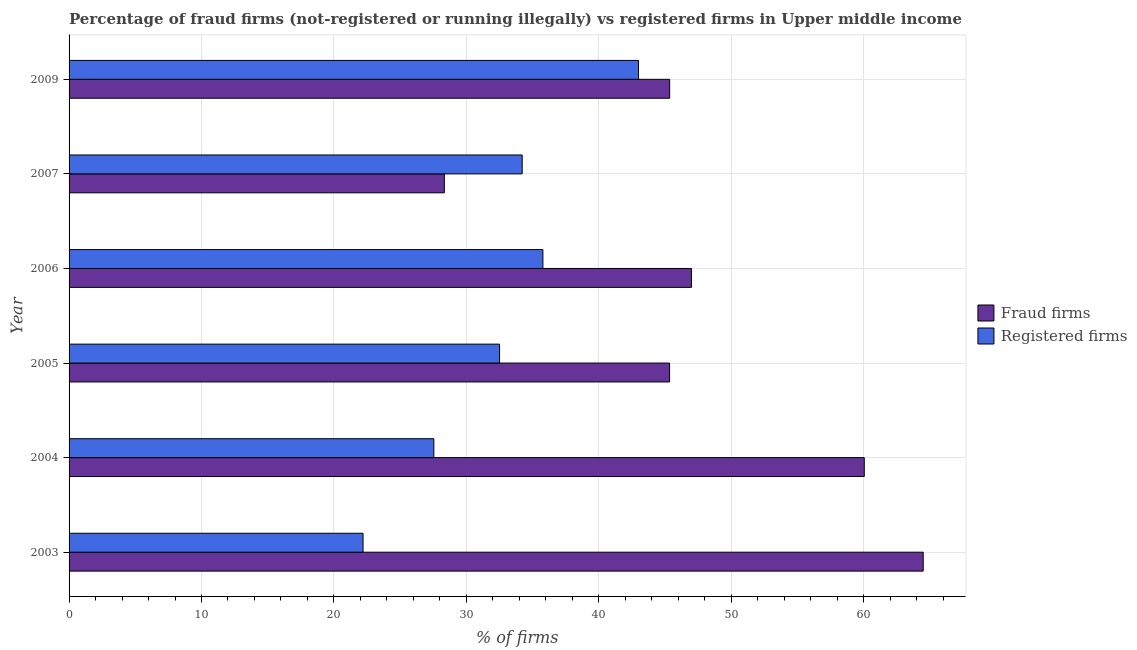How many groups of bars are there?
Make the answer very short. 6. Are the number of bars per tick equal to the number of legend labels?
Your answer should be very brief. Yes. How many bars are there on the 6th tick from the top?
Offer a terse response. 2. What is the percentage of fraud firms in 2005?
Your response must be concise. 45.35. Across all years, what is the minimum percentage of registered firms?
Offer a terse response. 22.2. What is the total percentage of fraud firms in the graph?
Give a very brief answer. 290.59. What is the difference between the percentage of registered firms in 2003 and that in 2006?
Offer a terse response. -13.58. What is the difference between the percentage of registered firms in 2003 and the percentage of fraud firms in 2004?
Your response must be concise. -37.85. What is the average percentage of fraud firms per year?
Give a very brief answer. 48.43. In the year 2006, what is the difference between the percentage of registered firms and percentage of fraud firms?
Offer a very short reply. -11.22. Is the percentage of fraud firms in 2004 less than that in 2006?
Keep it short and to the point. No. What is the difference between the highest and the second highest percentage of fraud firms?
Ensure brevity in your answer.  4.45. What is the difference between the highest and the lowest percentage of registered firms?
Keep it short and to the point. 20.8. What does the 1st bar from the top in 2009 represents?
Make the answer very short. Registered firms. What does the 2nd bar from the bottom in 2003 represents?
Your response must be concise. Registered firms. How many bars are there?
Give a very brief answer. 12. What is the difference between two consecutive major ticks on the X-axis?
Provide a succinct answer. 10. Does the graph contain any zero values?
Your answer should be compact. No. Does the graph contain grids?
Your answer should be very brief. Yes. How many legend labels are there?
Offer a terse response. 2. What is the title of the graph?
Your answer should be very brief. Percentage of fraud firms (not-registered or running illegally) vs registered firms in Upper middle income. Does "Chemicals" appear as one of the legend labels in the graph?
Offer a very short reply. No. What is the label or title of the X-axis?
Keep it short and to the point. % of firms. What is the % of firms of Fraud firms in 2003?
Your answer should be compact. 64.5. What is the % of firms of Fraud firms in 2004?
Offer a terse response. 60.05. What is the % of firms in Registered firms in 2004?
Ensure brevity in your answer.  27.55. What is the % of firms of Fraud firms in 2005?
Provide a short and direct response. 45.35. What is the % of firms in Registered firms in 2005?
Your response must be concise. 32.51. What is the % of firms in Fraud firms in 2006?
Give a very brief answer. 47. What is the % of firms in Registered firms in 2006?
Keep it short and to the point. 35.78. What is the % of firms of Fraud firms in 2007?
Give a very brief answer. 28.34. What is the % of firms in Registered firms in 2007?
Keep it short and to the point. 34.22. What is the % of firms of Fraud firms in 2009?
Provide a short and direct response. 45.35. Across all years, what is the maximum % of firms in Fraud firms?
Offer a terse response. 64.5. Across all years, what is the maximum % of firms in Registered firms?
Make the answer very short. 43. Across all years, what is the minimum % of firms in Fraud firms?
Provide a succinct answer. 28.34. Across all years, what is the minimum % of firms of Registered firms?
Offer a very short reply. 22.2. What is the total % of firms in Fraud firms in the graph?
Ensure brevity in your answer.  290.59. What is the total % of firms in Registered firms in the graph?
Offer a very short reply. 195.25. What is the difference between the % of firms of Fraud firms in 2003 and that in 2004?
Your response must be concise. 4.45. What is the difference between the % of firms in Registered firms in 2003 and that in 2004?
Your answer should be compact. -5.35. What is the difference between the % of firms in Fraud firms in 2003 and that in 2005?
Give a very brief answer. 19.15. What is the difference between the % of firms in Registered firms in 2003 and that in 2005?
Offer a very short reply. -10.31. What is the difference between the % of firms of Fraud firms in 2003 and that in 2006?
Your response must be concise. 17.5. What is the difference between the % of firms in Registered firms in 2003 and that in 2006?
Give a very brief answer. -13.58. What is the difference between the % of firms of Fraud firms in 2003 and that in 2007?
Give a very brief answer. 36.16. What is the difference between the % of firms in Registered firms in 2003 and that in 2007?
Make the answer very short. -12.02. What is the difference between the % of firms of Fraud firms in 2003 and that in 2009?
Make the answer very short. 19.15. What is the difference between the % of firms in Registered firms in 2003 and that in 2009?
Make the answer very short. -20.8. What is the difference between the % of firms of Fraud firms in 2004 and that in 2005?
Give a very brief answer. 14.7. What is the difference between the % of firms of Registered firms in 2004 and that in 2005?
Offer a terse response. -4.96. What is the difference between the % of firms of Fraud firms in 2004 and that in 2006?
Your response must be concise. 13.05. What is the difference between the % of firms in Registered firms in 2004 and that in 2006?
Provide a succinct answer. -8.23. What is the difference between the % of firms of Fraud firms in 2004 and that in 2007?
Your response must be concise. 31.71. What is the difference between the % of firms of Registered firms in 2004 and that in 2007?
Make the answer very short. -6.67. What is the difference between the % of firms in Fraud firms in 2004 and that in 2009?
Make the answer very short. 14.7. What is the difference between the % of firms in Registered firms in 2004 and that in 2009?
Offer a very short reply. -15.45. What is the difference between the % of firms of Fraud firms in 2005 and that in 2006?
Your answer should be very brief. -1.65. What is the difference between the % of firms of Registered firms in 2005 and that in 2006?
Offer a terse response. -3.27. What is the difference between the % of firms in Fraud firms in 2005 and that in 2007?
Offer a very short reply. 17.01. What is the difference between the % of firms of Registered firms in 2005 and that in 2007?
Give a very brief answer. -1.71. What is the difference between the % of firms of Fraud firms in 2005 and that in 2009?
Your answer should be compact. -0.01. What is the difference between the % of firms in Registered firms in 2005 and that in 2009?
Your answer should be compact. -10.49. What is the difference between the % of firms in Fraud firms in 2006 and that in 2007?
Make the answer very short. 18.66. What is the difference between the % of firms in Registered firms in 2006 and that in 2007?
Provide a succinct answer. 1.56. What is the difference between the % of firms of Fraud firms in 2006 and that in 2009?
Offer a terse response. 1.64. What is the difference between the % of firms in Registered firms in 2006 and that in 2009?
Keep it short and to the point. -7.22. What is the difference between the % of firms of Fraud firms in 2007 and that in 2009?
Make the answer very short. -17.01. What is the difference between the % of firms in Registered firms in 2007 and that in 2009?
Keep it short and to the point. -8.78. What is the difference between the % of firms of Fraud firms in 2003 and the % of firms of Registered firms in 2004?
Make the answer very short. 36.95. What is the difference between the % of firms of Fraud firms in 2003 and the % of firms of Registered firms in 2005?
Offer a very short reply. 31.99. What is the difference between the % of firms of Fraud firms in 2003 and the % of firms of Registered firms in 2006?
Provide a succinct answer. 28.72. What is the difference between the % of firms of Fraud firms in 2003 and the % of firms of Registered firms in 2007?
Provide a succinct answer. 30.28. What is the difference between the % of firms of Fraud firms in 2004 and the % of firms of Registered firms in 2005?
Provide a short and direct response. 27.54. What is the difference between the % of firms of Fraud firms in 2004 and the % of firms of Registered firms in 2006?
Give a very brief answer. 24.27. What is the difference between the % of firms in Fraud firms in 2004 and the % of firms in Registered firms in 2007?
Give a very brief answer. 25.83. What is the difference between the % of firms of Fraud firms in 2004 and the % of firms of Registered firms in 2009?
Your answer should be compact. 17.05. What is the difference between the % of firms of Fraud firms in 2005 and the % of firms of Registered firms in 2006?
Provide a succinct answer. 9.57. What is the difference between the % of firms of Fraud firms in 2005 and the % of firms of Registered firms in 2007?
Keep it short and to the point. 11.13. What is the difference between the % of firms of Fraud firms in 2005 and the % of firms of Registered firms in 2009?
Make the answer very short. 2.35. What is the difference between the % of firms in Fraud firms in 2006 and the % of firms in Registered firms in 2007?
Your answer should be very brief. 12.78. What is the difference between the % of firms of Fraud firms in 2006 and the % of firms of Registered firms in 2009?
Give a very brief answer. 4. What is the difference between the % of firms of Fraud firms in 2007 and the % of firms of Registered firms in 2009?
Ensure brevity in your answer.  -14.66. What is the average % of firms in Fraud firms per year?
Keep it short and to the point. 48.43. What is the average % of firms in Registered firms per year?
Provide a short and direct response. 32.54. In the year 2003, what is the difference between the % of firms of Fraud firms and % of firms of Registered firms?
Your answer should be very brief. 42.3. In the year 2004, what is the difference between the % of firms in Fraud firms and % of firms in Registered firms?
Provide a short and direct response. 32.5. In the year 2005, what is the difference between the % of firms in Fraud firms and % of firms in Registered firms?
Keep it short and to the point. 12.84. In the year 2006, what is the difference between the % of firms in Fraud firms and % of firms in Registered firms?
Offer a terse response. 11.22. In the year 2007, what is the difference between the % of firms of Fraud firms and % of firms of Registered firms?
Offer a very short reply. -5.88. In the year 2009, what is the difference between the % of firms of Fraud firms and % of firms of Registered firms?
Keep it short and to the point. 2.35. What is the ratio of the % of firms of Fraud firms in 2003 to that in 2004?
Your response must be concise. 1.07. What is the ratio of the % of firms in Registered firms in 2003 to that in 2004?
Offer a very short reply. 0.81. What is the ratio of the % of firms of Fraud firms in 2003 to that in 2005?
Offer a terse response. 1.42. What is the ratio of the % of firms of Registered firms in 2003 to that in 2005?
Provide a short and direct response. 0.68. What is the ratio of the % of firms in Fraud firms in 2003 to that in 2006?
Provide a short and direct response. 1.37. What is the ratio of the % of firms of Registered firms in 2003 to that in 2006?
Ensure brevity in your answer.  0.62. What is the ratio of the % of firms of Fraud firms in 2003 to that in 2007?
Offer a terse response. 2.28. What is the ratio of the % of firms in Registered firms in 2003 to that in 2007?
Ensure brevity in your answer.  0.65. What is the ratio of the % of firms of Fraud firms in 2003 to that in 2009?
Your answer should be compact. 1.42. What is the ratio of the % of firms of Registered firms in 2003 to that in 2009?
Keep it short and to the point. 0.52. What is the ratio of the % of firms of Fraud firms in 2004 to that in 2005?
Ensure brevity in your answer.  1.32. What is the ratio of the % of firms in Registered firms in 2004 to that in 2005?
Make the answer very short. 0.85. What is the ratio of the % of firms of Fraud firms in 2004 to that in 2006?
Offer a very short reply. 1.28. What is the ratio of the % of firms in Registered firms in 2004 to that in 2006?
Your response must be concise. 0.77. What is the ratio of the % of firms of Fraud firms in 2004 to that in 2007?
Offer a very short reply. 2.12. What is the ratio of the % of firms in Registered firms in 2004 to that in 2007?
Offer a very short reply. 0.81. What is the ratio of the % of firms of Fraud firms in 2004 to that in 2009?
Provide a short and direct response. 1.32. What is the ratio of the % of firms of Registered firms in 2004 to that in 2009?
Provide a short and direct response. 0.64. What is the ratio of the % of firms in Fraud firms in 2005 to that in 2006?
Your answer should be very brief. 0.96. What is the ratio of the % of firms of Registered firms in 2005 to that in 2006?
Offer a terse response. 0.91. What is the ratio of the % of firms of Fraud firms in 2005 to that in 2007?
Provide a short and direct response. 1.6. What is the ratio of the % of firms in Registered firms in 2005 to that in 2007?
Keep it short and to the point. 0.95. What is the ratio of the % of firms in Registered firms in 2005 to that in 2009?
Your answer should be very brief. 0.76. What is the ratio of the % of firms in Fraud firms in 2006 to that in 2007?
Make the answer very short. 1.66. What is the ratio of the % of firms in Registered firms in 2006 to that in 2007?
Offer a terse response. 1.05. What is the ratio of the % of firms in Fraud firms in 2006 to that in 2009?
Your answer should be very brief. 1.04. What is the ratio of the % of firms in Registered firms in 2006 to that in 2009?
Provide a succinct answer. 0.83. What is the ratio of the % of firms in Fraud firms in 2007 to that in 2009?
Give a very brief answer. 0.62. What is the ratio of the % of firms in Registered firms in 2007 to that in 2009?
Offer a very short reply. 0.8. What is the difference between the highest and the second highest % of firms in Fraud firms?
Ensure brevity in your answer.  4.45. What is the difference between the highest and the second highest % of firms of Registered firms?
Give a very brief answer. 7.22. What is the difference between the highest and the lowest % of firms in Fraud firms?
Provide a short and direct response. 36.16. What is the difference between the highest and the lowest % of firms of Registered firms?
Your answer should be very brief. 20.8. 